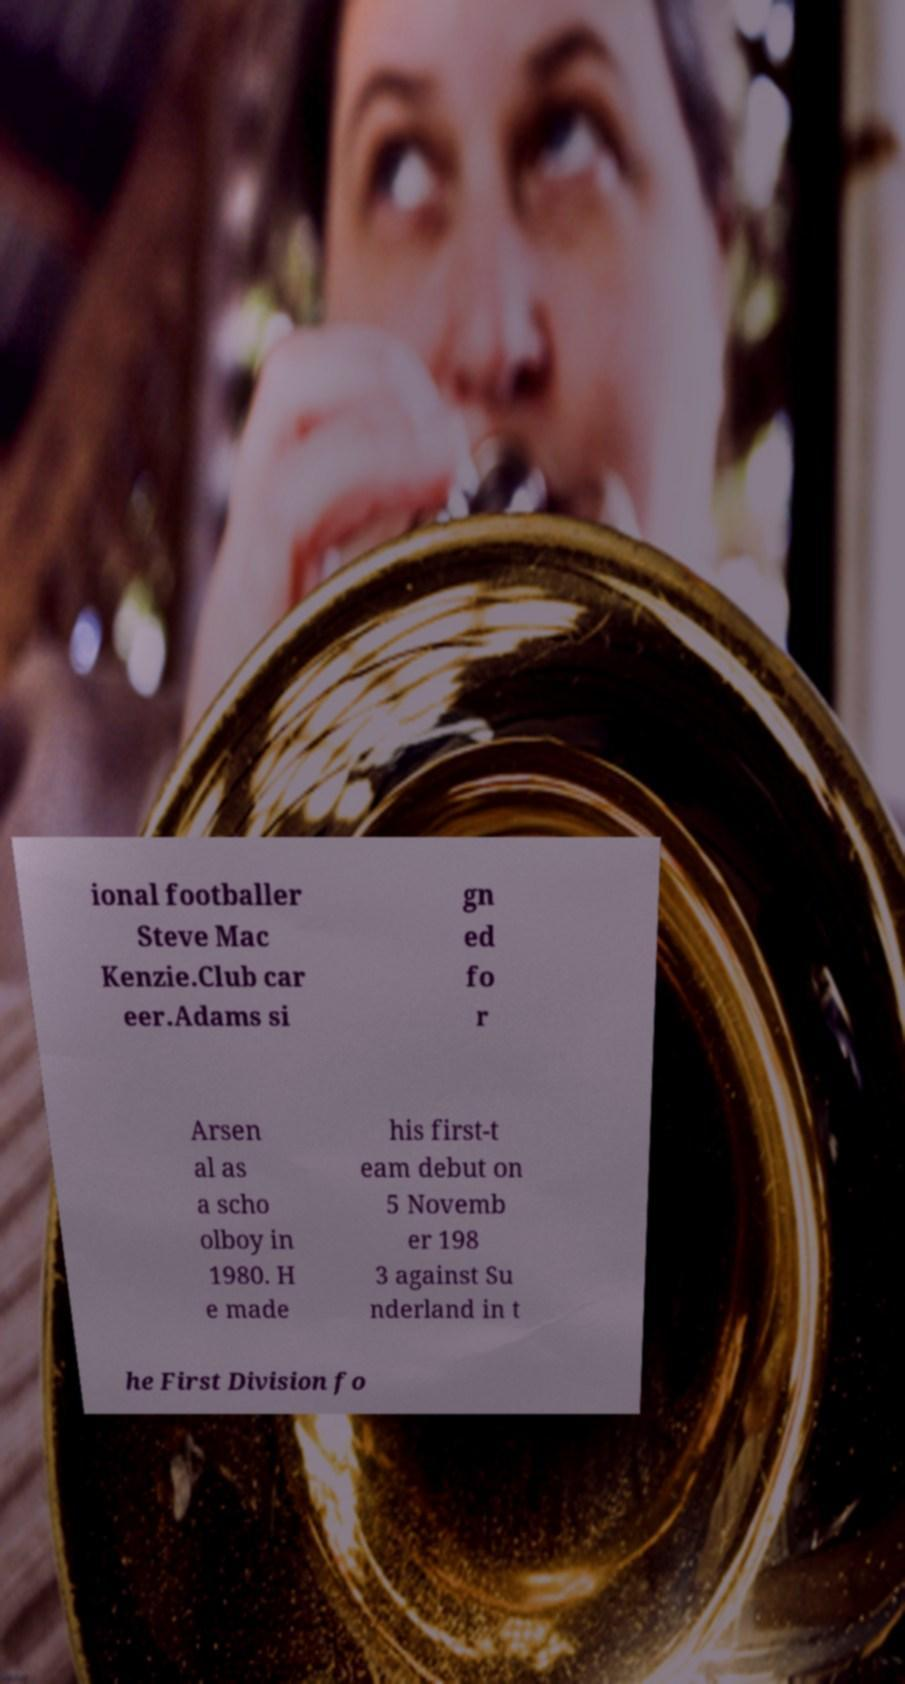Please read and relay the text visible in this image. What does it say? ional footballer Steve Mac Kenzie.Club car eer.Adams si gn ed fo r Arsen al as a scho olboy in 1980. H e made his first-t eam debut on 5 Novemb er 198 3 against Su nderland in t he First Division fo 